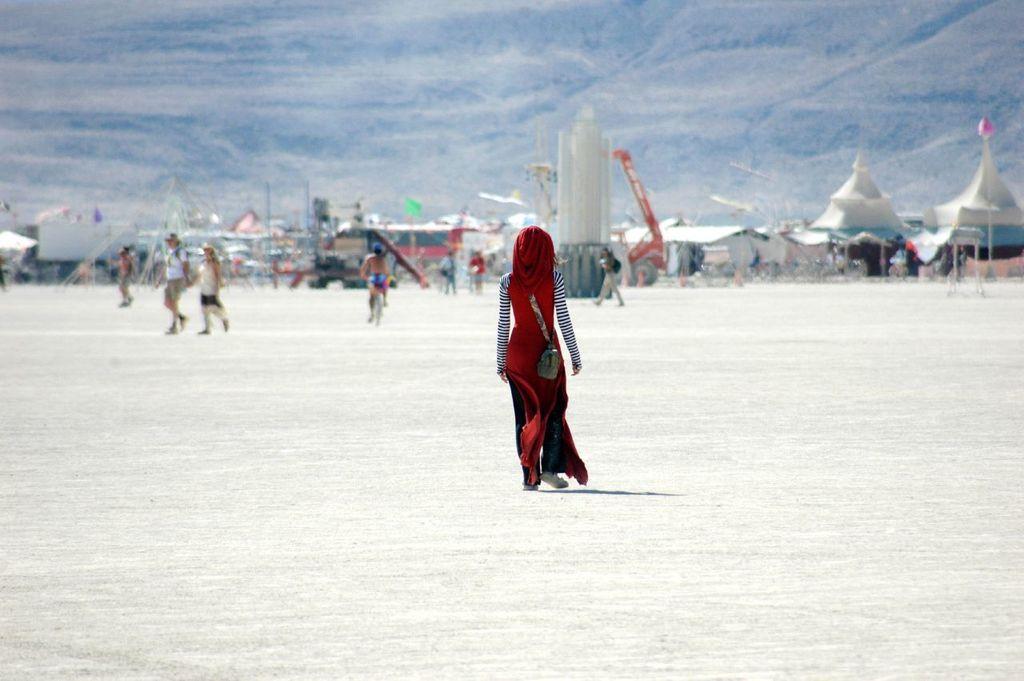Describe this image in one or two sentences. In this image we can see a person is walking on the vast land. Background of the image tents are there. At the top of the image sky is present. 